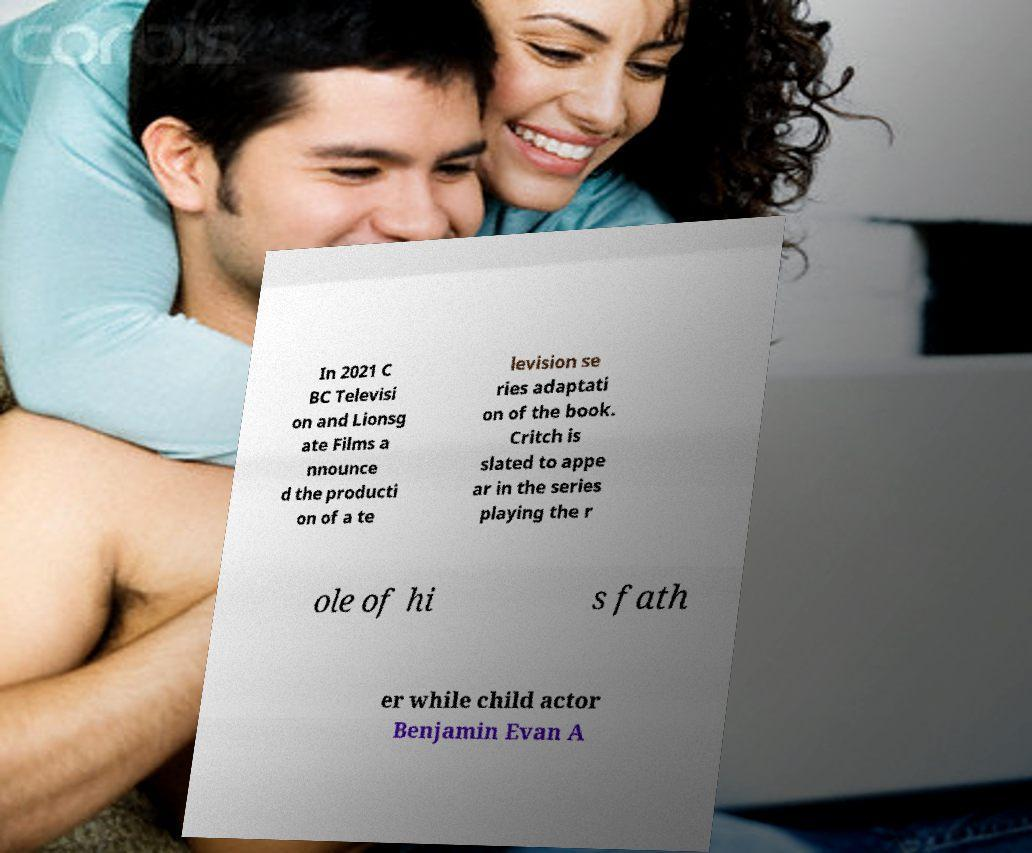Please identify and transcribe the text found in this image. In 2021 C BC Televisi on and Lionsg ate Films a nnounce d the producti on of a te levision se ries adaptati on of the book. Critch is slated to appe ar in the series playing the r ole of hi s fath er while child actor Benjamin Evan A 